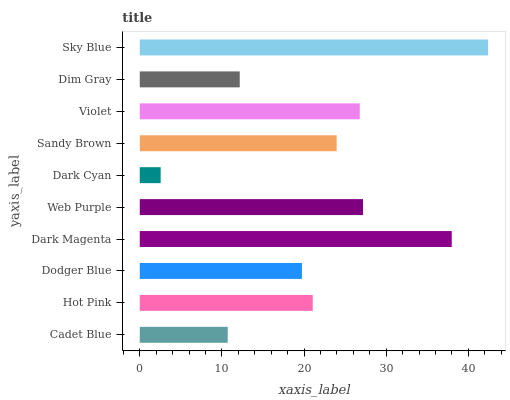Is Dark Cyan the minimum?
Answer yes or no. Yes. Is Sky Blue the maximum?
Answer yes or no. Yes. Is Hot Pink the minimum?
Answer yes or no. No. Is Hot Pink the maximum?
Answer yes or no. No. Is Hot Pink greater than Cadet Blue?
Answer yes or no. Yes. Is Cadet Blue less than Hot Pink?
Answer yes or no. Yes. Is Cadet Blue greater than Hot Pink?
Answer yes or no. No. Is Hot Pink less than Cadet Blue?
Answer yes or no. No. Is Sandy Brown the high median?
Answer yes or no. Yes. Is Hot Pink the low median?
Answer yes or no. Yes. Is Dim Gray the high median?
Answer yes or no. No. Is Sandy Brown the low median?
Answer yes or no. No. 